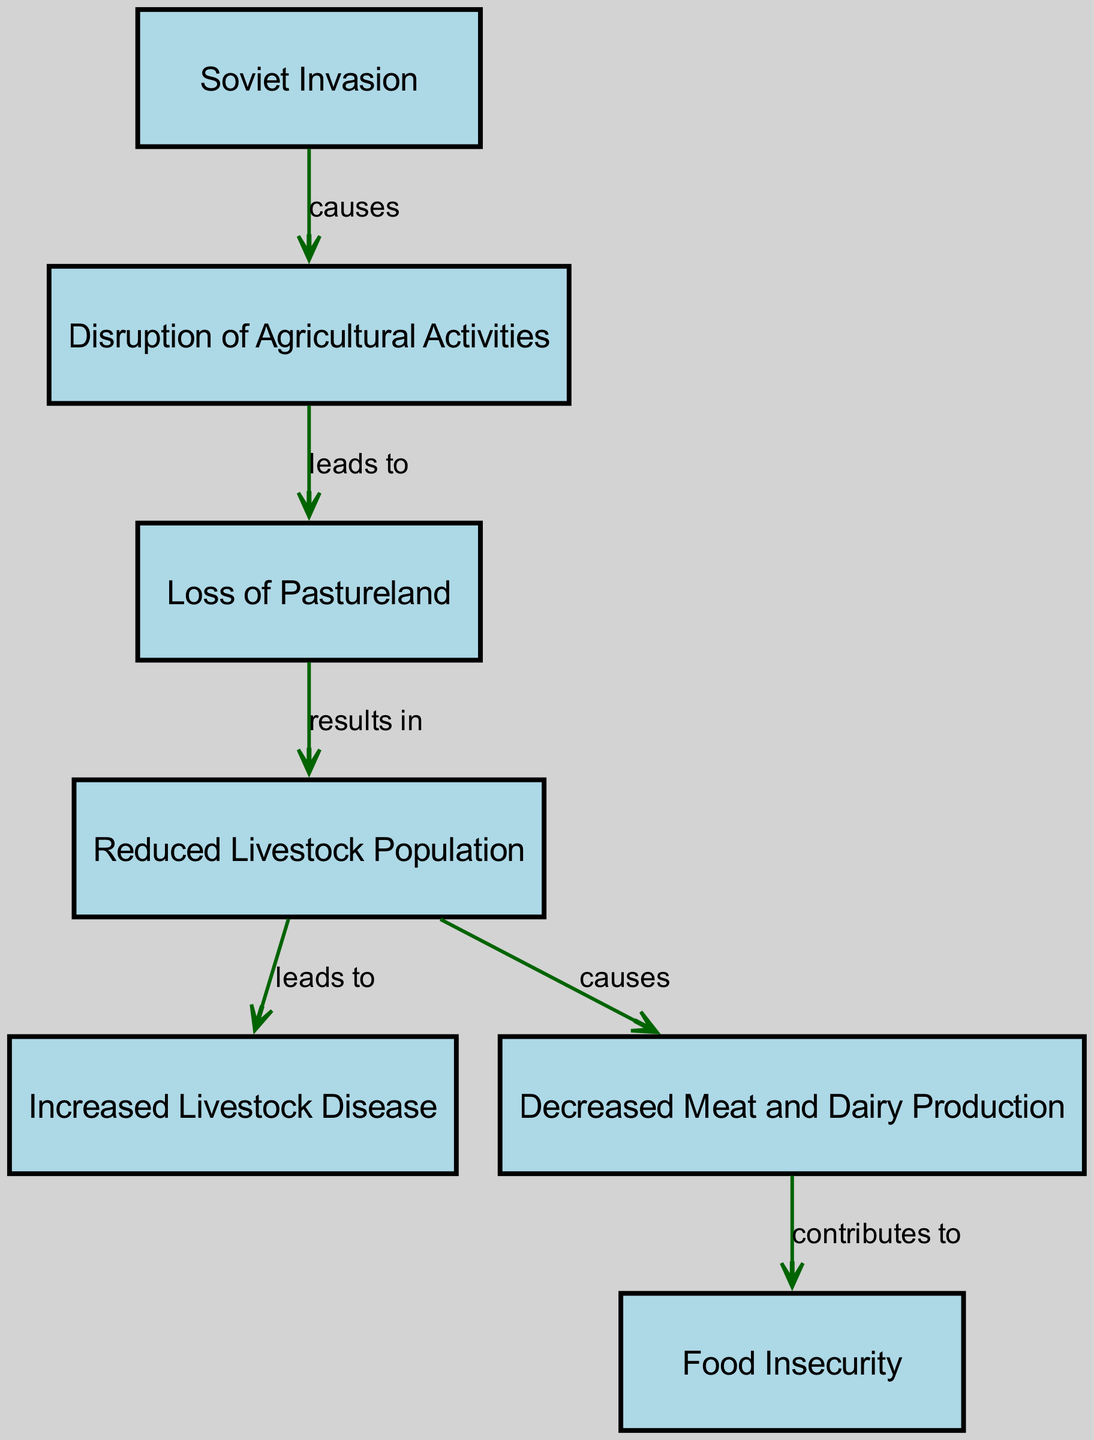What is the first element in the diagram? The first element is "Soviet Invasion," which is identified as the starting point of the relationships depicted in the diagram.
Answer: Soviet Invasion How many edges are there in total? The diagram contains six edges that connect the nodes and describe the relationships and impacts.
Answer: 6 What does the "Soviet Invasion" cause? According to the diagram, the "Soviet Invasion" causes "Disruption of Agricultural Activities." This is the direct relationship stemming from the first node.
Answer: Disruption of Agricultural Activities What is the outcome of "Loss of Pastureland"? The "Loss of Pastureland" results in "Reduced Livestock Population," as indicated by the directed edge stemming from that node.
Answer: Reduced Livestock Population What contributes to "Food Insecurity"? "Decreased Meat and Dairy Production" contributes to "Food Insecurity." This relationship is established in the diagram through the directed edge connecting these two nodes.
Answer: Decreased Meat and Dairy Production What is the relationship between "Reduced Livestock Population" and "Increased Livestock Disease"? "Reduced Livestock Population" leads to "Increased Livestock Disease," based on the direct flow of the diagram that describes this causal link.
Answer: leads to What leads to "Food Insecurity"? "Decreased Meat and Dairy Production" contributes to "Food Insecurity," which involved stepping through the sequence of impacts resulting from livestock issues ultimately affecting food availability.
Answer: Decreased Meat and Dairy Production How does "Loss of Pastureland" impact livestock? "Loss of Pastureland" results in "Reduced Livestock Population," indicating that the absence of grazing land directly affects the number of livestock that can be maintained.
Answer: Reduced Livestock Population What happens after "Disruption of Agricultural Activities"? After the "Disruption of Agricultural Activities," the next consequence is the "Loss of Pastureland," which shows a clear progression in the impacts introduced by the Soviet invasion on agriculture.
Answer: Loss of Pastureland 